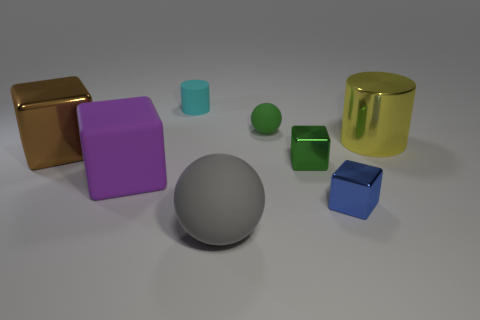How many cubes have the same color as the small matte ball?
Provide a succinct answer. 1. Is the color of the matte cylinder the same as the tiny rubber ball?
Keep it short and to the point. No. There is a big object that is on the right side of the small sphere; what is it made of?
Give a very brief answer. Metal. How many tiny things are purple blocks or brown balls?
Keep it short and to the point. 0. What material is the tiny thing that is the same color as the tiny sphere?
Give a very brief answer. Metal. Are there any small cyan spheres made of the same material as the large purple cube?
Provide a short and direct response. No. There is a purple matte block left of the green rubber ball; is it the same size as the brown thing?
Your answer should be compact. Yes. Are there any big cylinders on the left side of the rubber sphere behind the gray object that is in front of the tiny cyan matte cylinder?
Provide a succinct answer. No. How many shiny things are tiny red balls or spheres?
Ensure brevity in your answer.  0. What number of other things are the same shape as the big yellow object?
Give a very brief answer. 1. 